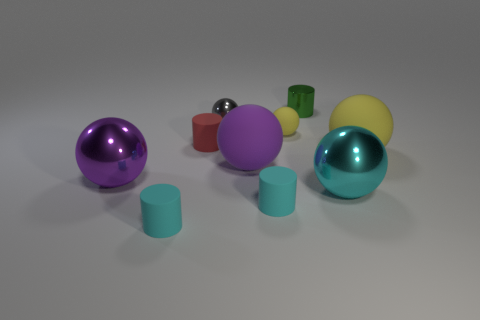There is a object that is both behind the small red object and on the right side of the small matte ball; what color is it? green 